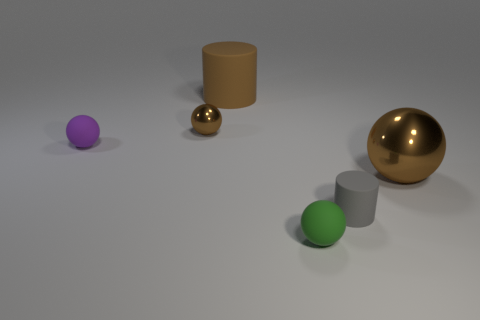Is the number of tiny brown metallic balls right of the tiny cylinder greater than the number of gray cylinders that are behind the brown cylinder?
Keep it short and to the point. No. How many purple balls are to the left of the big metal sphere?
Keep it short and to the point. 1. Are the tiny green object and the small object behind the purple ball made of the same material?
Offer a very short reply. No. Is there anything else that has the same shape as the gray object?
Keep it short and to the point. Yes. Is the material of the small purple object the same as the small green object?
Provide a short and direct response. Yes. There is a ball that is in front of the big brown metallic ball; is there a small brown ball that is right of it?
Make the answer very short. No. What number of cylinders are both in front of the tiny metal object and behind the tiny metal sphere?
Give a very brief answer. 0. What is the shape of the brown metal thing to the left of the big brown sphere?
Provide a succinct answer. Sphere. How many gray matte cylinders are the same size as the green rubber object?
Provide a succinct answer. 1. Is the color of the matte ball left of the small green matte object the same as the big metal thing?
Offer a terse response. No. 